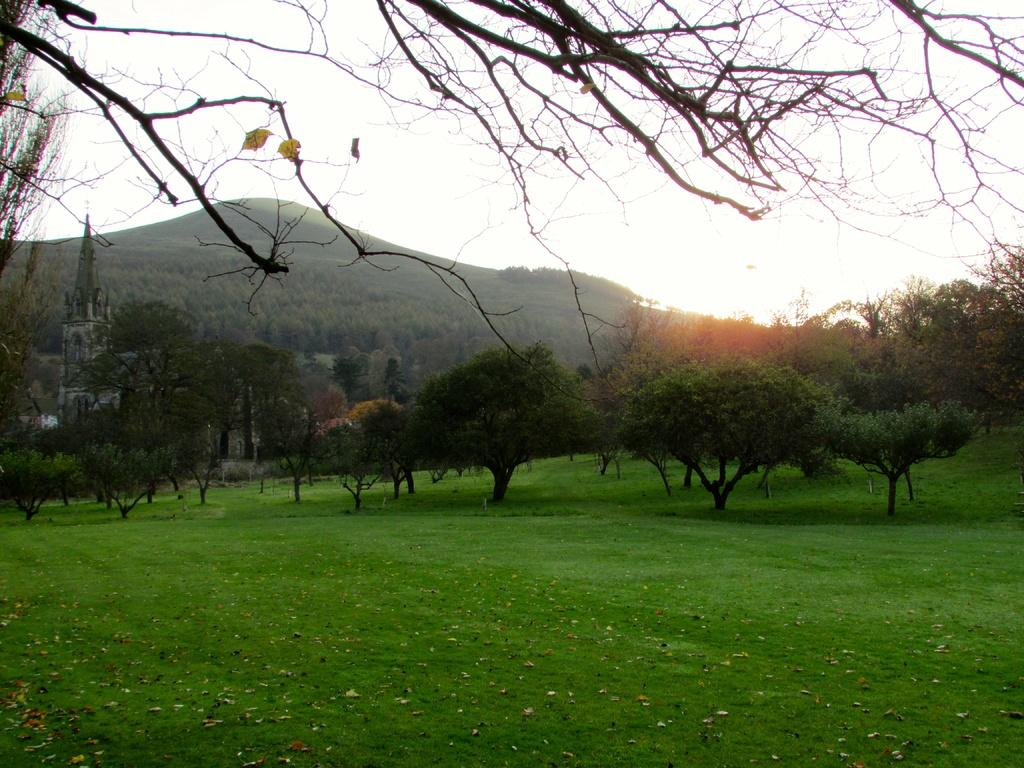What type of surface is visible in the image? There is a grass surface in the image. What can be seen in the image besides the grass surface? Trees and hills are visible in the image. Are there any trees on the hills? Yes, trees are present on the hills. What is visible in the background of the image? The sky is visible in the background of the image. How many books are stacked on the neck of the person in the image? There is no person or books present in the image. 